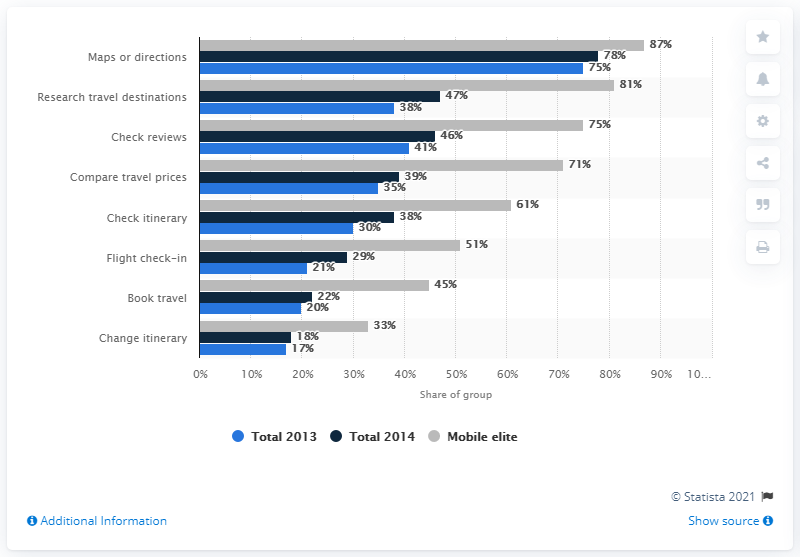Specify some key components in this picture. In 2014, out of all responses, how many were over 30%? There were 5 responses in total. The graph contains 8 different types of travel activities. 